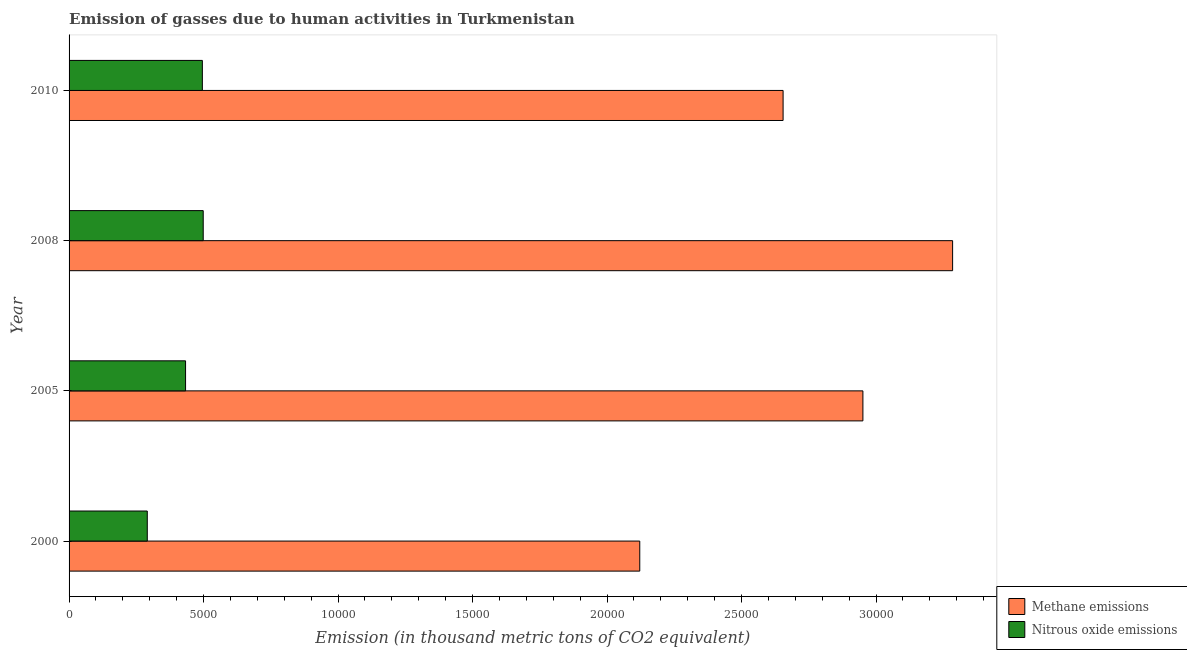How many bars are there on the 2nd tick from the bottom?
Offer a very short reply. 2. What is the amount of nitrous oxide emissions in 2005?
Offer a terse response. 4330.6. Across all years, what is the maximum amount of nitrous oxide emissions?
Keep it short and to the point. 4987.1. Across all years, what is the minimum amount of nitrous oxide emissions?
Provide a short and direct response. 2907.9. In which year was the amount of nitrous oxide emissions maximum?
Offer a terse response. 2008. What is the total amount of methane emissions in the graph?
Your answer should be very brief. 1.10e+05. What is the difference between the amount of nitrous oxide emissions in 2005 and that in 2008?
Give a very brief answer. -656.5. What is the difference between the amount of methane emissions in 2008 and the amount of nitrous oxide emissions in 2010?
Provide a short and direct response. 2.79e+04. What is the average amount of methane emissions per year?
Provide a succinct answer. 2.75e+04. In the year 2005, what is the difference between the amount of nitrous oxide emissions and amount of methane emissions?
Provide a succinct answer. -2.52e+04. What is the ratio of the amount of methane emissions in 2005 to that in 2008?
Offer a very short reply. 0.9. What is the difference between the highest and the second highest amount of nitrous oxide emissions?
Make the answer very short. 31.9. What is the difference between the highest and the lowest amount of methane emissions?
Provide a succinct answer. 1.16e+04. Is the sum of the amount of methane emissions in 2000 and 2005 greater than the maximum amount of nitrous oxide emissions across all years?
Keep it short and to the point. Yes. What does the 1st bar from the top in 2000 represents?
Make the answer very short. Nitrous oxide emissions. What does the 1st bar from the bottom in 2000 represents?
Provide a short and direct response. Methane emissions. How many bars are there?
Ensure brevity in your answer.  8. How many years are there in the graph?
Provide a short and direct response. 4. What is the difference between two consecutive major ticks on the X-axis?
Give a very brief answer. 5000. Does the graph contain any zero values?
Your answer should be very brief. No. Where does the legend appear in the graph?
Keep it short and to the point. Bottom right. How are the legend labels stacked?
Your answer should be very brief. Vertical. What is the title of the graph?
Your answer should be compact. Emission of gasses due to human activities in Turkmenistan. Does "Personal remittances" appear as one of the legend labels in the graph?
Your answer should be very brief. No. What is the label or title of the X-axis?
Provide a short and direct response. Emission (in thousand metric tons of CO2 equivalent). What is the Emission (in thousand metric tons of CO2 equivalent) in Methane emissions in 2000?
Offer a very short reply. 2.12e+04. What is the Emission (in thousand metric tons of CO2 equivalent) in Nitrous oxide emissions in 2000?
Your answer should be compact. 2907.9. What is the Emission (in thousand metric tons of CO2 equivalent) in Methane emissions in 2005?
Offer a terse response. 2.95e+04. What is the Emission (in thousand metric tons of CO2 equivalent) in Nitrous oxide emissions in 2005?
Provide a succinct answer. 4330.6. What is the Emission (in thousand metric tons of CO2 equivalent) of Methane emissions in 2008?
Make the answer very short. 3.28e+04. What is the Emission (in thousand metric tons of CO2 equivalent) of Nitrous oxide emissions in 2008?
Provide a short and direct response. 4987.1. What is the Emission (in thousand metric tons of CO2 equivalent) of Methane emissions in 2010?
Offer a terse response. 2.65e+04. What is the Emission (in thousand metric tons of CO2 equivalent) in Nitrous oxide emissions in 2010?
Your response must be concise. 4955.2. Across all years, what is the maximum Emission (in thousand metric tons of CO2 equivalent) of Methane emissions?
Your response must be concise. 3.28e+04. Across all years, what is the maximum Emission (in thousand metric tons of CO2 equivalent) in Nitrous oxide emissions?
Give a very brief answer. 4987.1. Across all years, what is the minimum Emission (in thousand metric tons of CO2 equivalent) of Methane emissions?
Offer a terse response. 2.12e+04. Across all years, what is the minimum Emission (in thousand metric tons of CO2 equivalent) of Nitrous oxide emissions?
Keep it short and to the point. 2907.9. What is the total Emission (in thousand metric tons of CO2 equivalent) of Methane emissions in the graph?
Make the answer very short. 1.10e+05. What is the total Emission (in thousand metric tons of CO2 equivalent) in Nitrous oxide emissions in the graph?
Keep it short and to the point. 1.72e+04. What is the difference between the Emission (in thousand metric tons of CO2 equivalent) in Methane emissions in 2000 and that in 2005?
Keep it short and to the point. -8296.1. What is the difference between the Emission (in thousand metric tons of CO2 equivalent) of Nitrous oxide emissions in 2000 and that in 2005?
Provide a short and direct response. -1422.7. What is the difference between the Emission (in thousand metric tons of CO2 equivalent) of Methane emissions in 2000 and that in 2008?
Provide a short and direct response. -1.16e+04. What is the difference between the Emission (in thousand metric tons of CO2 equivalent) in Nitrous oxide emissions in 2000 and that in 2008?
Give a very brief answer. -2079.2. What is the difference between the Emission (in thousand metric tons of CO2 equivalent) in Methane emissions in 2000 and that in 2010?
Keep it short and to the point. -5328.9. What is the difference between the Emission (in thousand metric tons of CO2 equivalent) of Nitrous oxide emissions in 2000 and that in 2010?
Your answer should be compact. -2047.3. What is the difference between the Emission (in thousand metric tons of CO2 equivalent) of Methane emissions in 2005 and that in 2008?
Keep it short and to the point. -3334.8. What is the difference between the Emission (in thousand metric tons of CO2 equivalent) of Nitrous oxide emissions in 2005 and that in 2008?
Provide a succinct answer. -656.5. What is the difference between the Emission (in thousand metric tons of CO2 equivalent) in Methane emissions in 2005 and that in 2010?
Your response must be concise. 2967.2. What is the difference between the Emission (in thousand metric tons of CO2 equivalent) of Nitrous oxide emissions in 2005 and that in 2010?
Make the answer very short. -624.6. What is the difference between the Emission (in thousand metric tons of CO2 equivalent) of Methane emissions in 2008 and that in 2010?
Give a very brief answer. 6302. What is the difference between the Emission (in thousand metric tons of CO2 equivalent) of Nitrous oxide emissions in 2008 and that in 2010?
Provide a succinct answer. 31.9. What is the difference between the Emission (in thousand metric tons of CO2 equivalent) of Methane emissions in 2000 and the Emission (in thousand metric tons of CO2 equivalent) of Nitrous oxide emissions in 2005?
Your answer should be compact. 1.69e+04. What is the difference between the Emission (in thousand metric tons of CO2 equivalent) in Methane emissions in 2000 and the Emission (in thousand metric tons of CO2 equivalent) in Nitrous oxide emissions in 2008?
Offer a very short reply. 1.62e+04. What is the difference between the Emission (in thousand metric tons of CO2 equivalent) in Methane emissions in 2000 and the Emission (in thousand metric tons of CO2 equivalent) in Nitrous oxide emissions in 2010?
Make the answer very short. 1.63e+04. What is the difference between the Emission (in thousand metric tons of CO2 equivalent) of Methane emissions in 2005 and the Emission (in thousand metric tons of CO2 equivalent) of Nitrous oxide emissions in 2008?
Your answer should be very brief. 2.45e+04. What is the difference between the Emission (in thousand metric tons of CO2 equivalent) in Methane emissions in 2005 and the Emission (in thousand metric tons of CO2 equivalent) in Nitrous oxide emissions in 2010?
Offer a terse response. 2.46e+04. What is the difference between the Emission (in thousand metric tons of CO2 equivalent) of Methane emissions in 2008 and the Emission (in thousand metric tons of CO2 equivalent) of Nitrous oxide emissions in 2010?
Your answer should be very brief. 2.79e+04. What is the average Emission (in thousand metric tons of CO2 equivalent) in Methane emissions per year?
Make the answer very short. 2.75e+04. What is the average Emission (in thousand metric tons of CO2 equivalent) of Nitrous oxide emissions per year?
Make the answer very short. 4295.2. In the year 2000, what is the difference between the Emission (in thousand metric tons of CO2 equivalent) of Methane emissions and Emission (in thousand metric tons of CO2 equivalent) of Nitrous oxide emissions?
Provide a succinct answer. 1.83e+04. In the year 2005, what is the difference between the Emission (in thousand metric tons of CO2 equivalent) of Methane emissions and Emission (in thousand metric tons of CO2 equivalent) of Nitrous oxide emissions?
Your answer should be very brief. 2.52e+04. In the year 2008, what is the difference between the Emission (in thousand metric tons of CO2 equivalent) of Methane emissions and Emission (in thousand metric tons of CO2 equivalent) of Nitrous oxide emissions?
Your response must be concise. 2.79e+04. In the year 2010, what is the difference between the Emission (in thousand metric tons of CO2 equivalent) of Methane emissions and Emission (in thousand metric tons of CO2 equivalent) of Nitrous oxide emissions?
Keep it short and to the point. 2.16e+04. What is the ratio of the Emission (in thousand metric tons of CO2 equivalent) of Methane emissions in 2000 to that in 2005?
Offer a very short reply. 0.72. What is the ratio of the Emission (in thousand metric tons of CO2 equivalent) in Nitrous oxide emissions in 2000 to that in 2005?
Keep it short and to the point. 0.67. What is the ratio of the Emission (in thousand metric tons of CO2 equivalent) in Methane emissions in 2000 to that in 2008?
Make the answer very short. 0.65. What is the ratio of the Emission (in thousand metric tons of CO2 equivalent) in Nitrous oxide emissions in 2000 to that in 2008?
Ensure brevity in your answer.  0.58. What is the ratio of the Emission (in thousand metric tons of CO2 equivalent) of Methane emissions in 2000 to that in 2010?
Your answer should be compact. 0.8. What is the ratio of the Emission (in thousand metric tons of CO2 equivalent) in Nitrous oxide emissions in 2000 to that in 2010?
Provide a succinct answer. 0.59. What is the ratio of the Emission (in thousand metric tons of CO2 equivalent) of Methane emissions in 2005 to that in 2008?
Ensure brevity in your answer.  0.9. What is the ratio of the Emission (in thousand metric tons of CO2 equivalent) of Nitrous oxide emissions in 2005 to that in 2008?
Provide a short and direct response. 0.87. What is the ratio of the Emission (in thousand metric tons of CO2 equivalent) in Methane emissions in 2005 to that in 2010?
Offer a very short reply. 1.11. What is the ratio of the Emission (in thousand metric tons of CO2 equivalent) of Nitrous oxide emissions in 2005 to that in 2010?
Your answer should be compact. 0.87. What is the ratio of the Emission (in thousand metric tons of CO2 equivalent) in Methane emissions in 2008 to that in 2010?
Your answer should be compact. 1.24. What is the ratio of the Emission (in thousand metric tons of CO2 equivalent) in Nitrous oxide emissions in 2008 to that in 2010?
Give a very brief answer. 1.01. What is the difference between the highest and the second highest Emission (in thousand metric tons of CO2 equivalent) in Methane emissions?
Offer a terse response. 3334.8. What is the difference between the highest and the second highest Emission (in thousand metric tons of CO2 equivalent) of Nitrous oxide emissions?
Offer a terse response. 31.9. What is the difference between the highest and the lowest Emission (in thousand metric tons of CO2 equivalent) in Methane emissions?
Your answer should be very brief. 1.16e+04. What is the difference between the highest and the lowest Emission (in thousand metric tons of CO2 equivalent) in Nitrous oxide emissions?
Your response must be concise. 2079.2. 